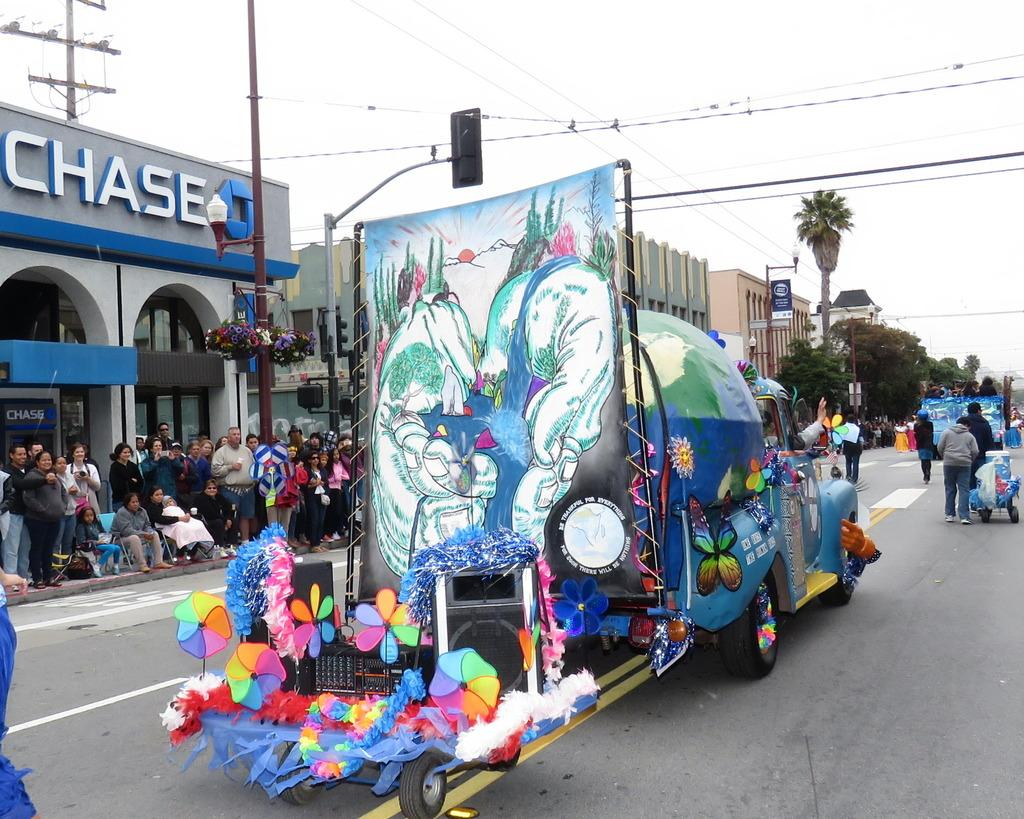<image>
Relay a brief, clear account of the picture shown. Colorful parade floats are passing the Chase building. 